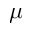<formula> <loc_0><loc_0><loc_500><loc_500>\mu</formula> 